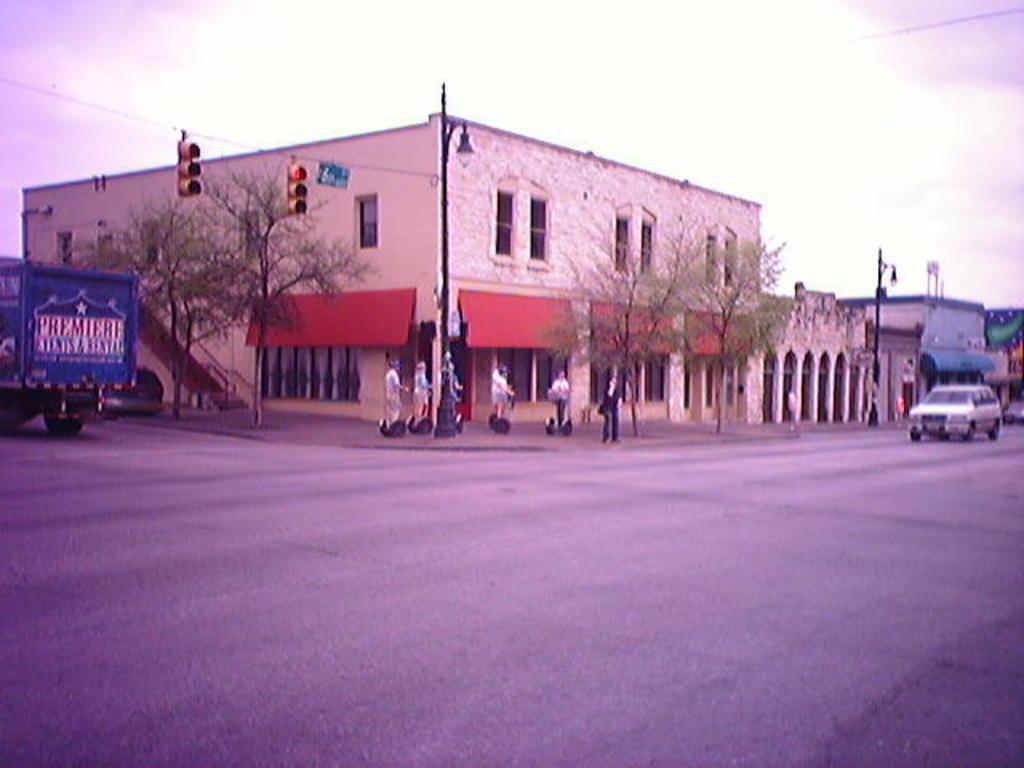How would you summarize this image in a sentence or two? The picture is taken outside a city on the street. In the foreground of the picture it is road. On the right there is a car. On the left there is a truck. In the center of the picture there are buildings, street lights, trees, signal lights and cables. This is an edited picture. 